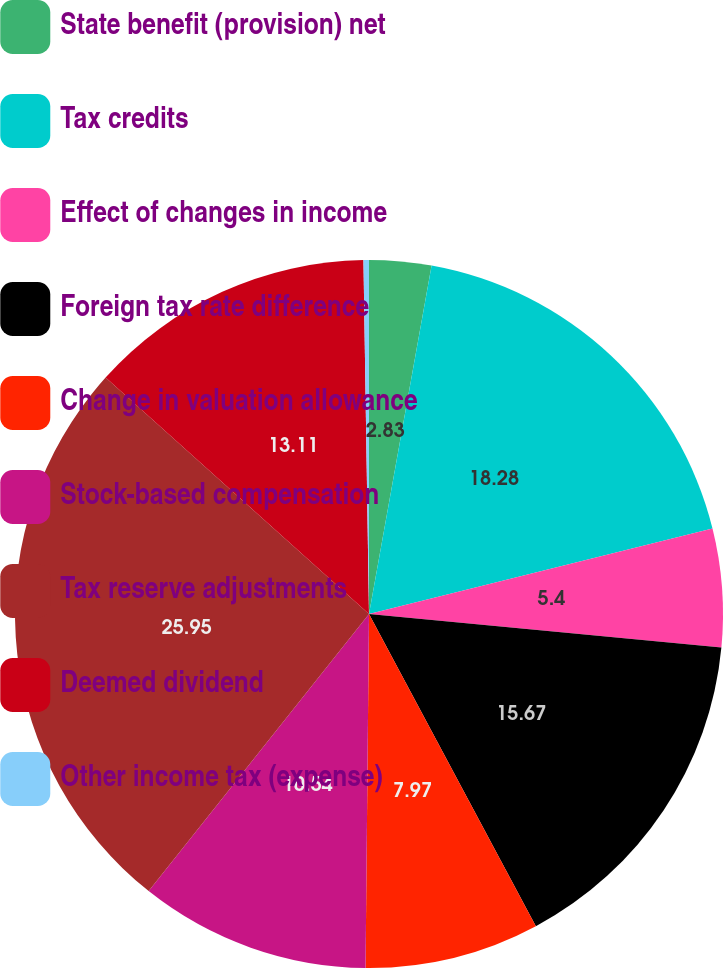<chart> <loc_0><loc_0><loc_500><loc_500><pie_chart><fcel>State benefit (provision) net<fcel>Tax credits<fcel>Effect of changes in income<fcel>Foreign tax rate difference<fcel>Change in valuation allowance<fcel>Stock-based compensation<fcel>Tax reserve adjustments<fcel>Deemed dividend<fcel>Other income tax (expense)<nl><fcel>2.83%<fcel>18.29%<fcel>5.4%<fcel>15.68%<fcel>7.97%<fcel>10.54%<fcel>25.96%<fcel>13.11%<fcel>0.25%<nl></chart> 